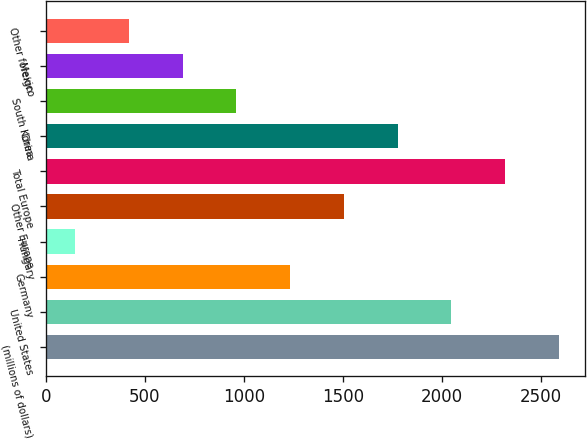<chart> <loc_0><loc_0><loc_500><loc_500><bar_chart><fcel>(millions of dollars)<fcel>United States<fcel>Germany<fcel>Hungary<fcel>Other Europe<fcel>Total Europe<fcel>China<fcel>South Korea<fcel>Mexico<fcel>Other foreign<nl><fcel>2592.17<fcel>2048.91<fcel>1234.02<fcel>147.5<fcel>1505.65<fcel>2320.54<fcel>1777.28<fcel>962.39<fcel>690.76<fcel>419.13<nl></chart> 